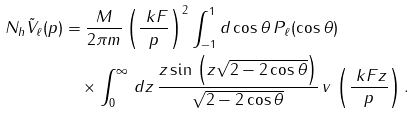Convert formula to latex. <formula><loc_0><loc_0><loc_500><loc_500>N _ { h } \tilde { V } _ { \ell } ( p ) & = \frac { M } { 2 \pi m } \left ( \frac { \ k F } { p } \right ) ^ { 2 } \int _ { - 1 } ^ { 1 } d \cos \theta \, P _ { \ell } ( \cos \theta ) \\ & \quad \times \int _ { 0 } ^ { \infty } \, d z \, \frac { z \sin \, \left ( z \sqrt { 2 - 2 \cos \theta } \right ) } { \sqrt { 2 - 2 \cos \theta } } \, v \, \left ( \frac { \ k F z } { p } \right ) .</formula> 